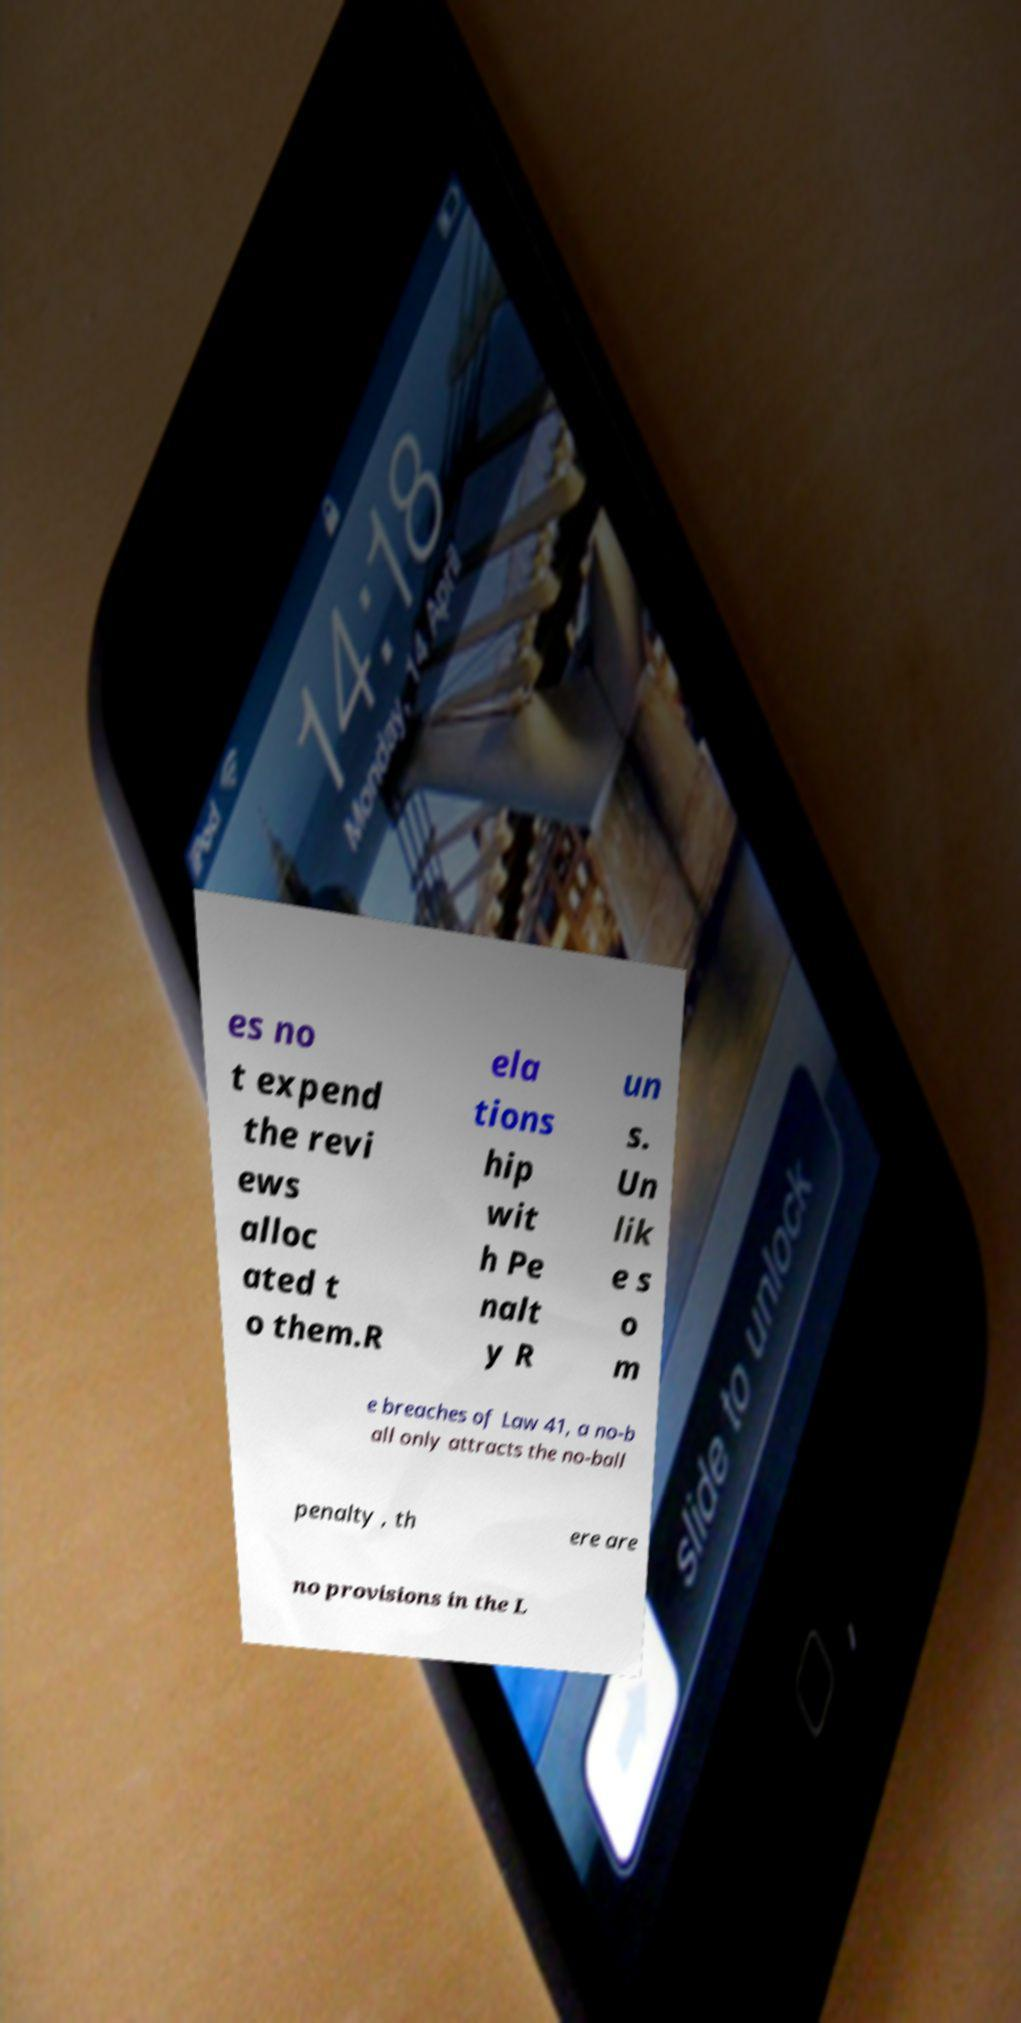Could you assist in decoding the text presented in this image and type it out clearly? es no t expend the revi ews alloc ated t o them.R ela tions hip wit h Pe nalt y R un s. Un lik e s o m e breaches of Law 41, a no-b all only attracts the no-ball penalty , th ere are no provisions in the L 